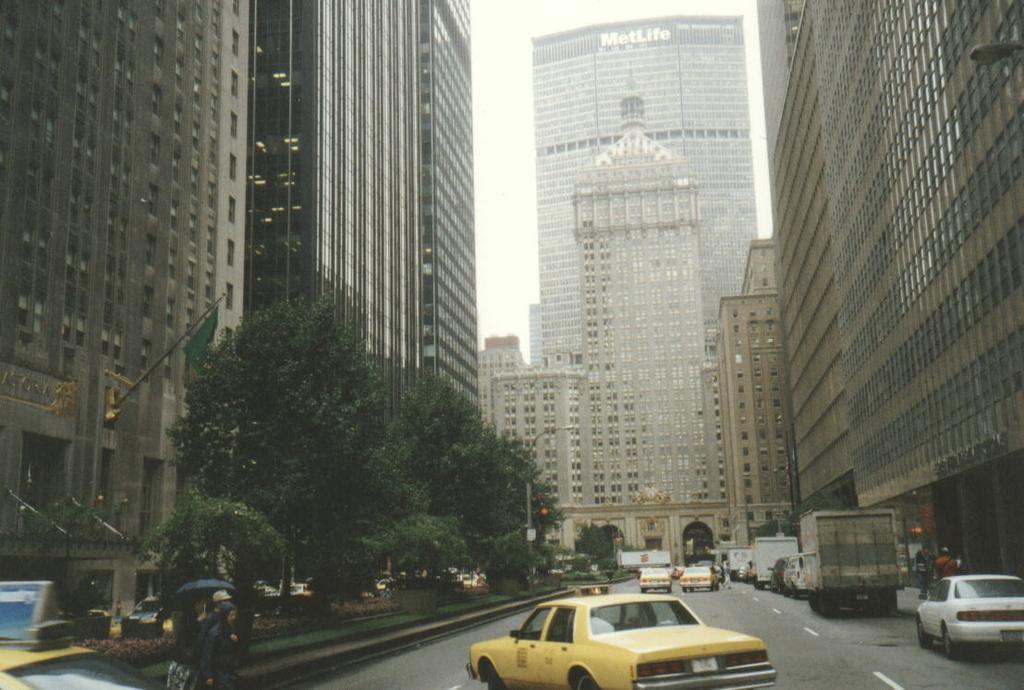<image>
Provide a brief description of the given image. The MetLife building in New York can be seen behind another building. 